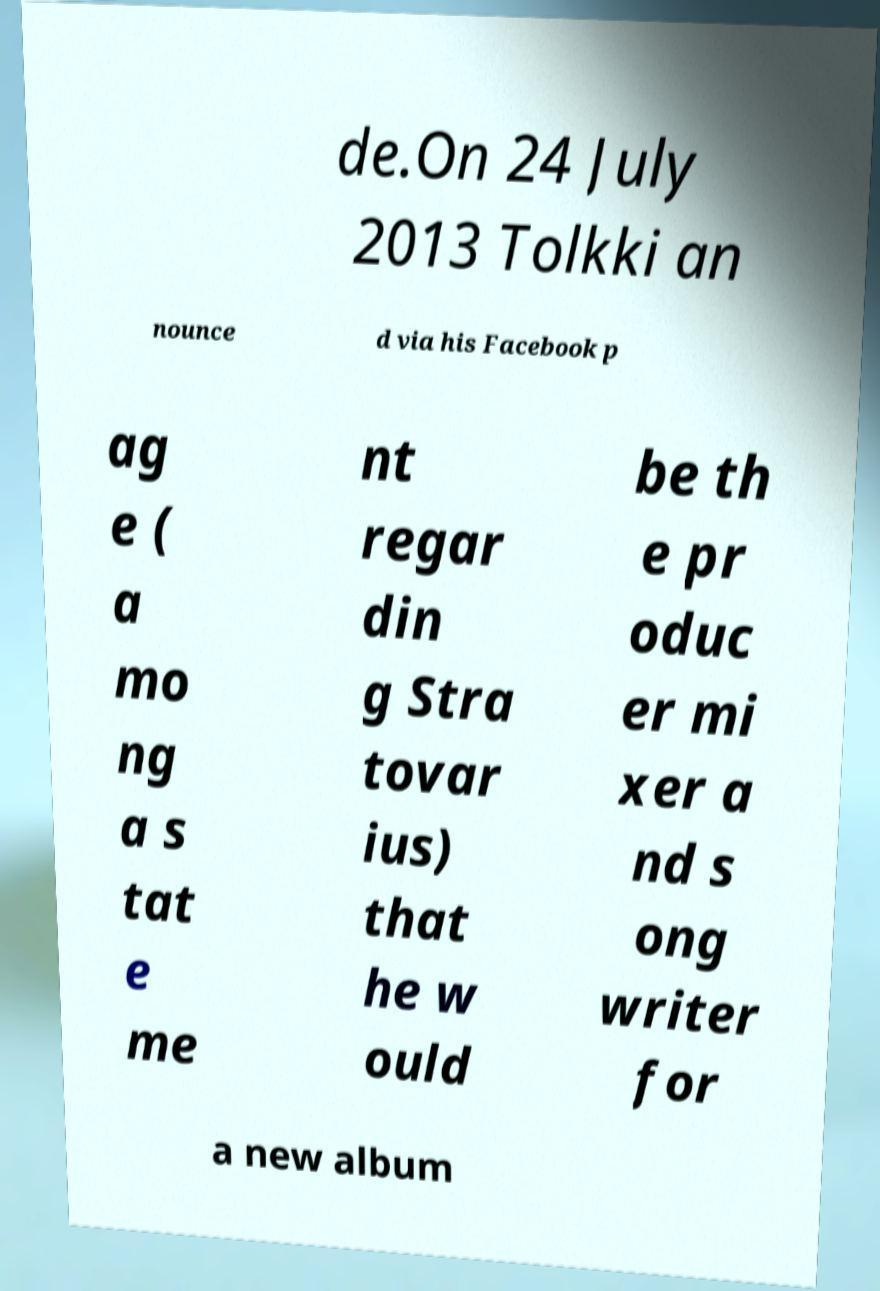Can you accurately transcribe the text from the provided image for me? de.On 24 July 2013 Tolkki an nounce d via his Facebook p ag e ( a mo ng a s tat e me nt regar din g Stra tovar ius) that he w ould be th e pr oduc er mi xer a nd s ong writer for a new album 